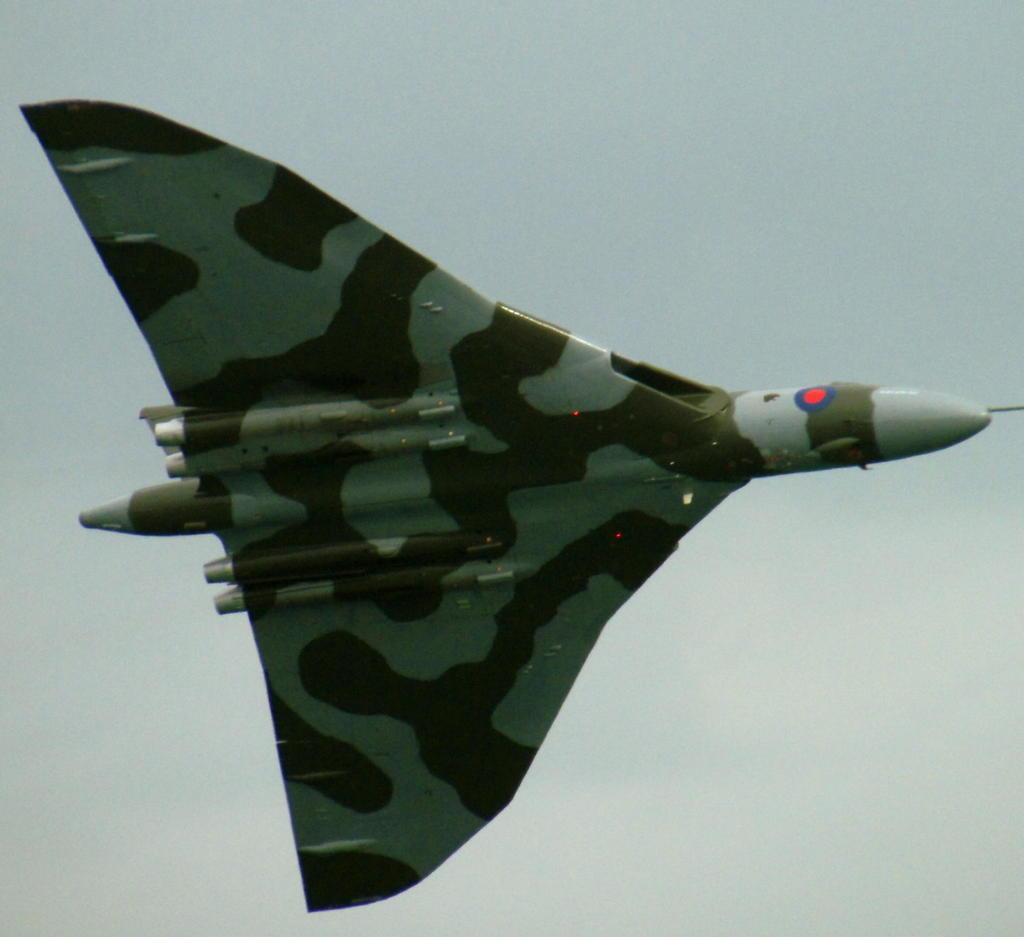What is the main subject of the image? The main subject of the image is an aircraft. What is the aircraft doing in the image? The aircraft is flying in the air. What can be seen in the background of the image? The sky is visible in the background of the image. How many sticks are being held by the aircraft in the image? There are no sticks present in the image, as the main subject is an aircraft flying in the air. 